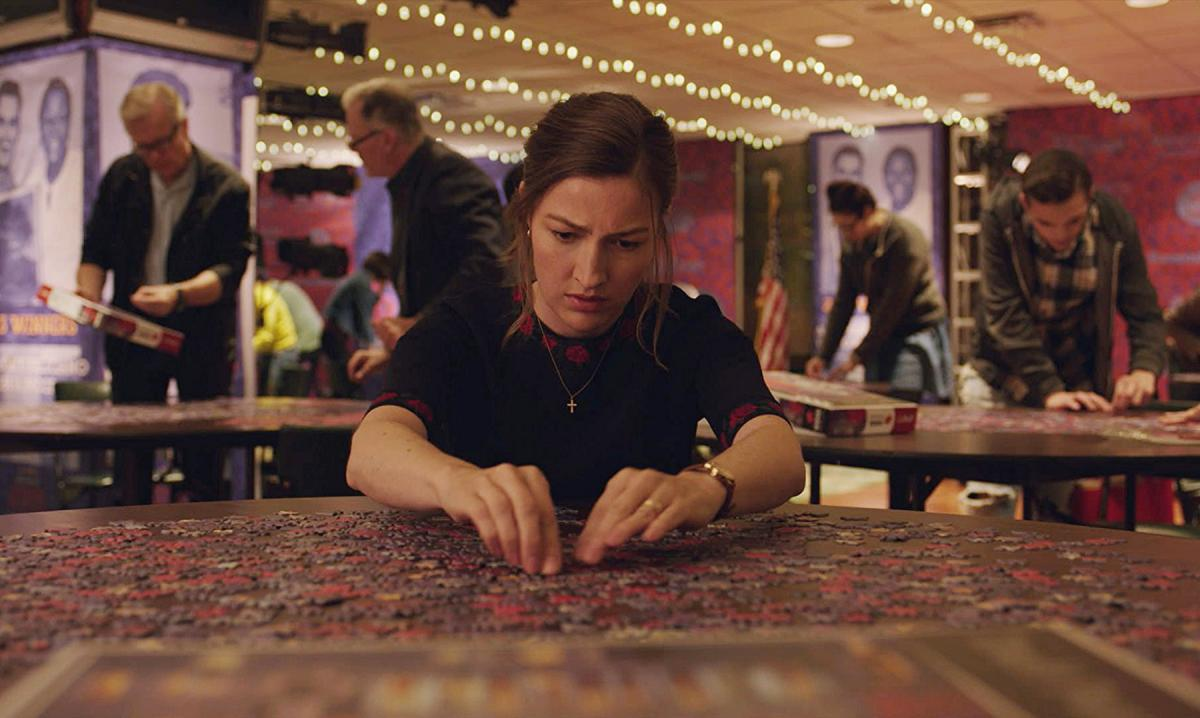Can you describe the emotions that might be felt by the person in this image? The woman in the image seems to exhibit a mixture of concentration and determination. Her slightly furrowed brow and focused expression suggest that she is deeply involved in solving the puzzle, possibly experiencing the intellectual challenge and satisfaction that comes from engaging with such a complex task. 